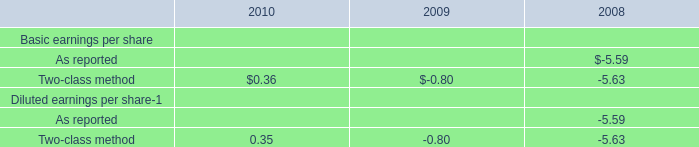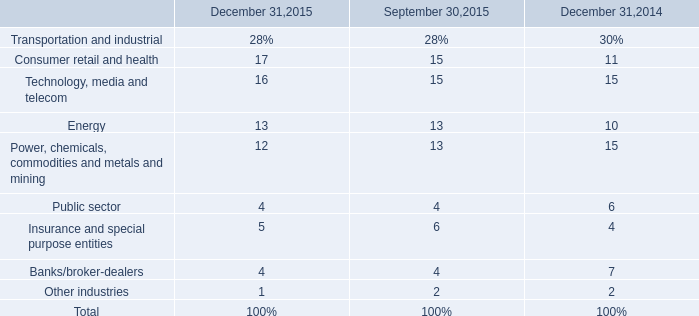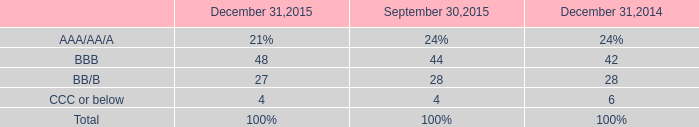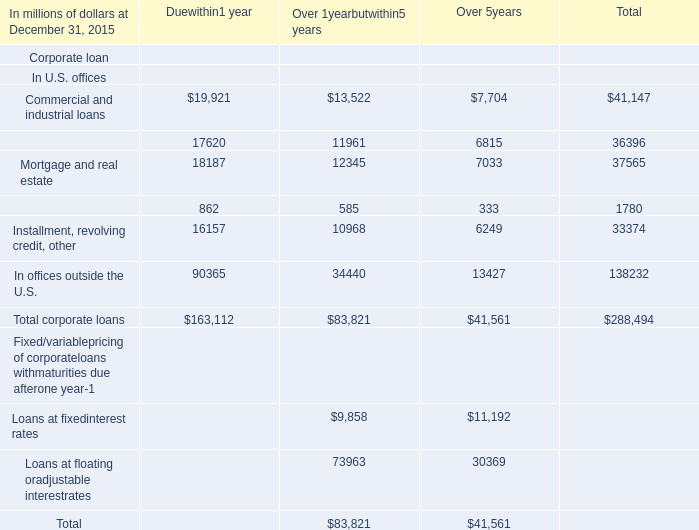What is the total value of Commercial and industrial loans, Financial institutions, Mortgage and real estate and Lease financing in in 2015 for Total ? (in million) 
Computations: (((41147 + 36396) + 37565) + 1780)
Answer: 116888.0. 